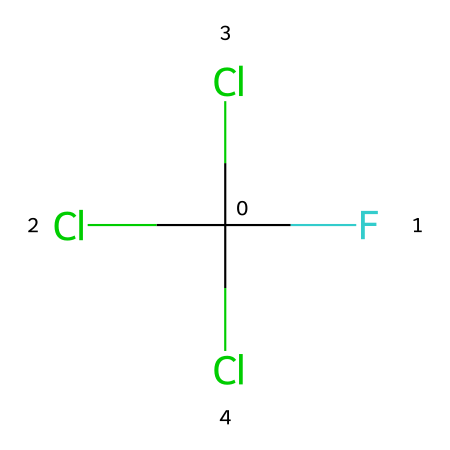What is the chemical name of this compound? The molecule represented by the provided SMILES corresponds to a chlorofluorocarbon, commonly referred to as CFC or more specifically dichlorodifluoromethane, which is recognized by its traditional nomenclature.
Answer: dichlorodifluoromethane How many carbon atoms are present in this molecule? The SMILES notation indicates one carbon atom (C) in the molecular structure, as the 'C' represents the carbon atom at the center of this CFC.
Answer: 1 How many chlorines are in this compound? In the SMILES representation, there are three 'Cl' symbols, indicating there are three chlorine atoms bonded to the carbon atom in this CFC.
Answer: 3 What type of bonds are present between carbon and chlorine? The connections between the carbon atom and each chlorine atom are single covalent bonds, signified by the adjacent placement of 'C' and 'Cl' in the SMILES without any other notations implying multiple bonds.
Answer: single covalent bonds What environmental effect is associated with this molecule? This molecule is known to be an ozone-depleting substance, meaning that its release into the atmosphere can lead to the breakdown of ozone molecules, contributing to ozone layer depletion.
Answer: ozone-depleting What is the total number of atoms in this chemical? To find the total number of atoms, we count the carbon (1), chlorine (3), and fluorine (2) atoms shown in the SMILES. This adds up to a total of six atoms in this compound.
Answer: 6 What gas is produced when this compound is broken down in the atmosphere? When chlorofluorocarbons like this one are broken down, they can release chlorine atoms which can react with ozone, leading to the production of oxygen gas.
Answer: oxygen 